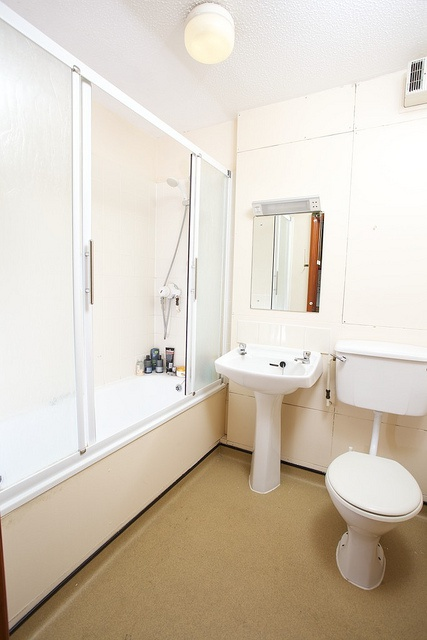Describe the objects in this image and their specific colors. I can see toilet in lightgray, darkgray, and gray tones and sink in lightgray, white, and darkgray tones in this image. 